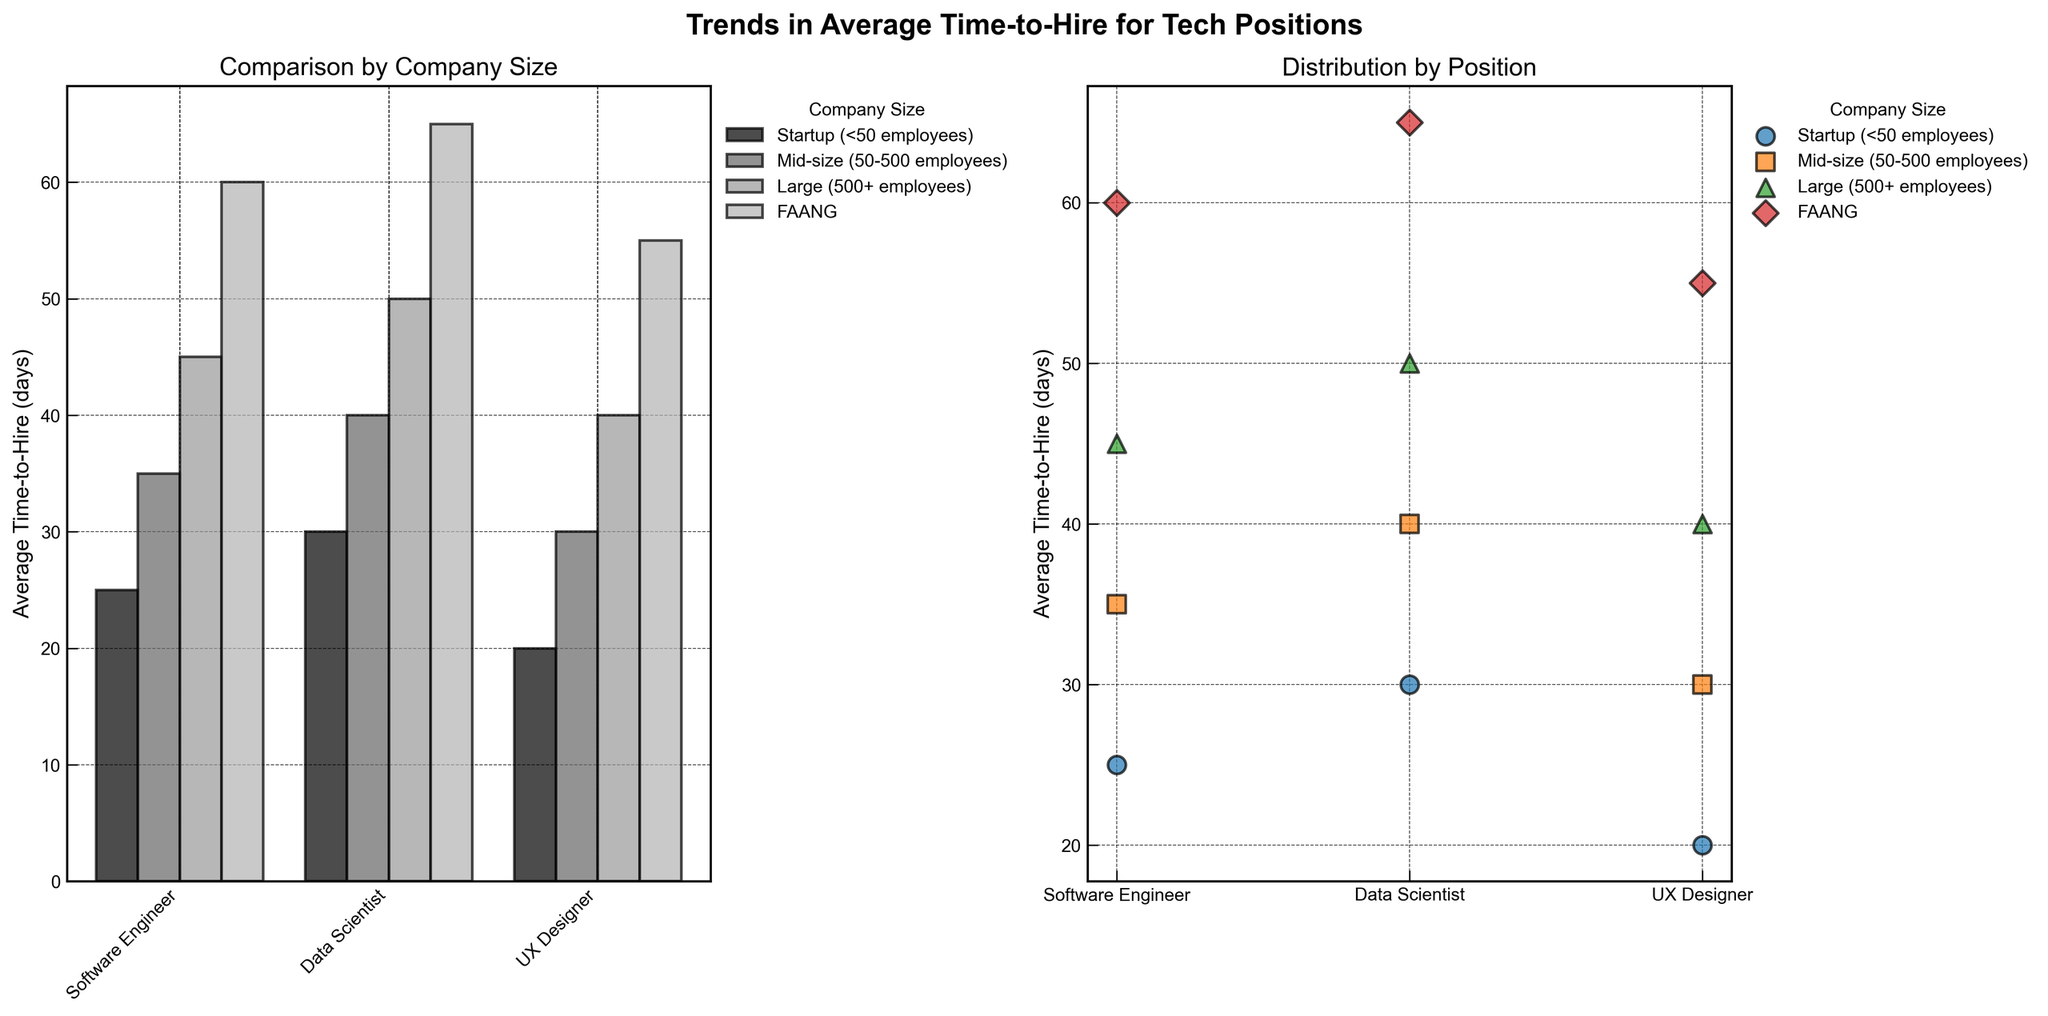What's the title of the figure? The title is located at the top of the figure and gives an overview of the content being visualized. It reads "Trends in Average Time-to-Hire for Tech Positions".
Answer: Trends in Average Time-to-Hire for Tech Positions Which company size has the longest average time-to-hire for a Software Engineer? By examining the bar plot, the tallest bar for Software Engineer positions is under the FAANG category. This indicates FAANG companies have the longest average time-to-hire for Software Engineers.
Answer: FAANG How does the average time-to-hire for Data Scientists compare between Startups and Large companies? By comparing the bar heights for Data Scientist positions, we see that the bar for Large companies is taller than the one for Startups. This means Large companies have a longer average time-to-hire for Data Scientists compared to Startups.
Answer: Longer in Large companies What's the difference in average time-to-hire between a UX Designer in a Startup and a Software Engineer in a FAANG company? From the bar plot, the average time-to-hire for a UX Designer in a Startup is 20 days, and for a Software Engineer in a FAANG company it is 60 days. The difference is 60 - 20 = 40 days.
Answer: 40 days Which position shows the smallest variation in average time-to-hire across different company sizes? In the scatter plot, look for the position where the points are closest together along the y-axis. The UX Designer has the smallest overall spread in points, indicating the least variation in time-to-hire across company sizes.
Answer: UX Designer Rank the positions by average time-to-hire from shortest to longest for Mid-size companies. For Mid-size companies, examine the bar heights for each position. The bars from shortest to longest are UX Designer (30), Software Engineer (35), and Data Scientist (40).
Answer: UX Designer, Software Engineer, Data Scientist Which position has the largest average time-to-hire for FAANG companies according to the scatter plot? Look at the scatter plot and identify the higher point for the positions under the label FAANG. The Data Scientist position has the highest point, indicating the largest average time-to-hire.
Answer: Data Scientist What is the average time-to-hire for Software Engineers across all company sizes (excluding FAANG)? From the scatter plot, sum the average time-to-hires for Software Engineers in Startup, Mid-size, and Large companies (25 + 35 + 45). Then divide by the number of companies (3). So, (25 + 35 + 45) / 3 = 35.
Answer: 35 days How much longer, on average, does it take to hire a Data Scientist compared to a UX Designer in Large companies? From the bar plot, the average time-to-hire for a Data Scientist in Large companies is 50 days, and for a UX Designer it is 40 days. The difference is 50 - 40 = 10 days.
Answer: 10 days 